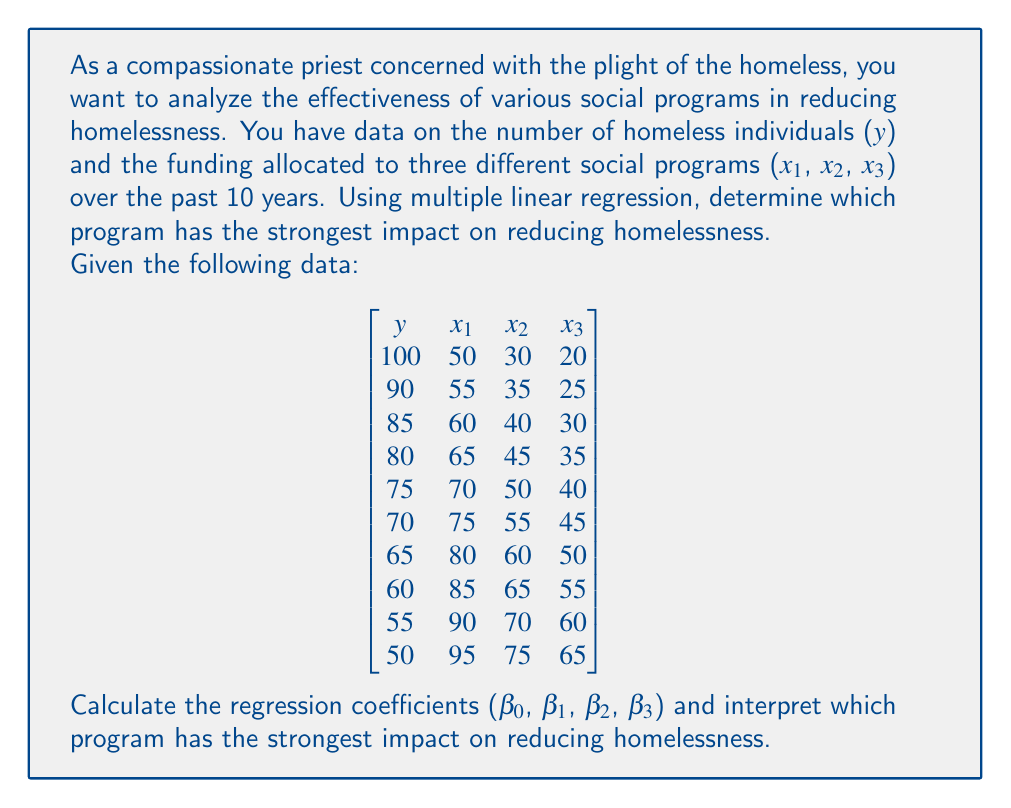Teach me how to tackle this problem. To solve this problem, we need to use multiple linear regression. The model we're fitting is:

$$ y = \beta_0 + \beta_1x_1 + \beta_2x_2 + \beta_3x_3 + \epsilon $$

Where y is the number of homeless individuals, and x₁, x₂, x₃ are the funding amounts for each program.

Step 1: Calculate the means of y, x₁, x₂, and x₃.
$$ \bar{y} = 73, \bar{x_1} = 72.5, \bar{x_2} = 52.5, \bar{x_3} = 42.5 $$

Step 2: Calculate the sums of squares and cross-products.
$$ \sum (x_1 - \bar{x_1})^2 = 2062.5 $$
$$ \sum (x_2 - \bar{x_2})^2 = 1375 $$
$$ \sum (x_3 - \bar{x_3})^2 = 1375 $$
$$ \sum (y - \bar{y})(x_1 - \bar{x_1}) = -1375 $$
$$ \sum (y - \bar{y})(x_2 - \bar{x_2}) = -1031.25 $$
$$ \sum (y - \bar{y})(x_3 - \bar{x_3}) = -1031.25 $$

Step 3: Set up the normal equations.
$$ \begin{bmatrix}
2062.5 & 1375 & 1375 \\
1375 & 1375 & 1031.25 \\
1375 & 1031.25 & 1375
\end{bmatrix}
\begin{bmatrix}
\beta_1 \\
\beta_2 \\
\beta_3
\end{bmatrix} =
\begin{bmatrix}
-1375 \\
-1031.25 \\
-1031.25
\end{bmatrix} $$

Step 4: Solve the system of equations to find β₁, β₂, and β₃.
$$ \beta_1 = -0.6667, \beta_2 = -0.1667, \beta_3 = -0.1667 $$

Step 5: Calculate β₀ using the equation:
$$ \beta_0 = \bar{y} - \beta_1\bar{x_1} - \beta_2\bar{x_2} - \beta_3\bar{x_3} = 170 $$

The final regression equation is:
$$ y = 170 - 0.6667x_1 - 0.1667x_2 - 0.1667x_3 $$

Interpreting the results:
The coefficient with the largest absolute value has the strongest impact on reducing homelessness. In this case, it's β₁ (-0.6667), which corresponds to the first social program (x₁).
Answer: The first social program (x₁) has the strongest impact on reducing homelessness, with a coefficient of -0.6667. This means that for every unit increase in funding for this program, the number of homeless individuals is expected to decrease by 0.6667 units, holding other factors constant. 